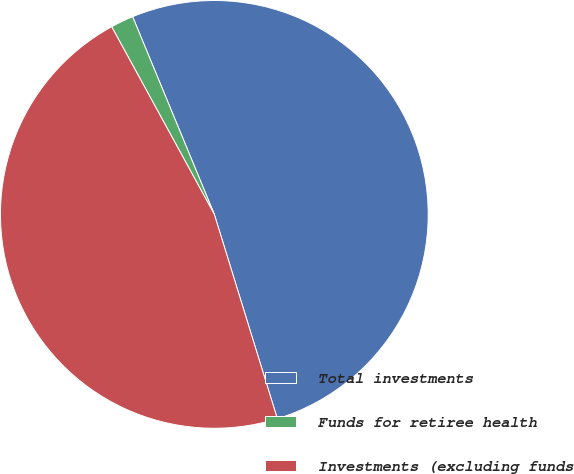<chart> <loc_0><loc_0><loc_500><loc_500><pie_chart><fcel>Total investments<fcel>Funds for retiree health<fcel>Investments (excluding funds<nl><fcel>51.47%<fcel>1.73%<fcel>46.79%<nl></chart> 